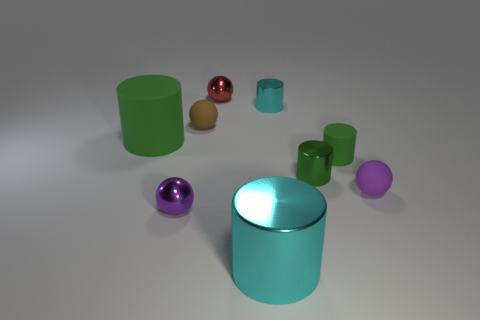Is there any pattern or symmetry in how the objects are arranged? The arrangement of objects appears to be random rather than symmetrical or following a discernible pattern. 